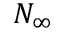<formula> <loc_0><loc_0><loc_500><loc_500>N _ { \infty }</formula> 